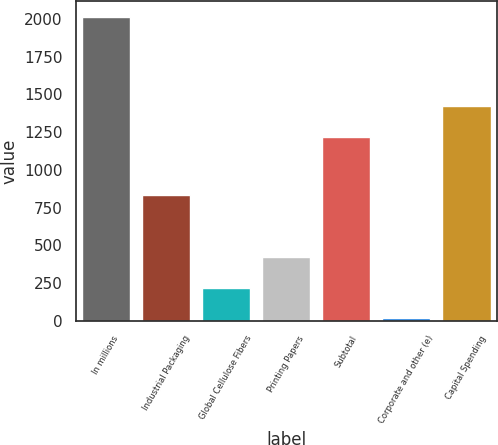<chart> <loc_0><loc_0><loc_500><loc_500><bar_chart><fcel>In millions<fcel>Industrial Packaging<fcel>Global Cellulose Fibers<fcel>Printing Papers<fcel>Subtotal<fcel>Corporate and other (e)<fcel>Capital Spending<nl><fcel>2016<fcel>832<fcel>219.6<fcel>419.2<fcel>1221<fcel>20<fcel>1420.6<nl></chart> 